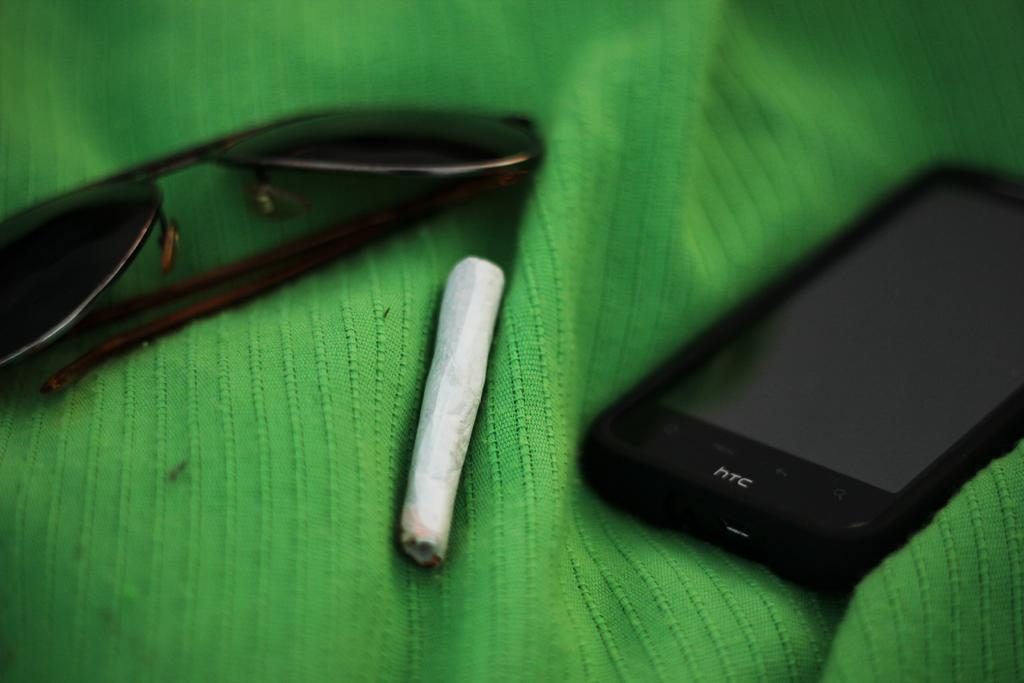Provide a one-sentence caption for the provided image. An HTC brand phone is laying on a green cloth next to a cigarette and a pair of sunglasses. 